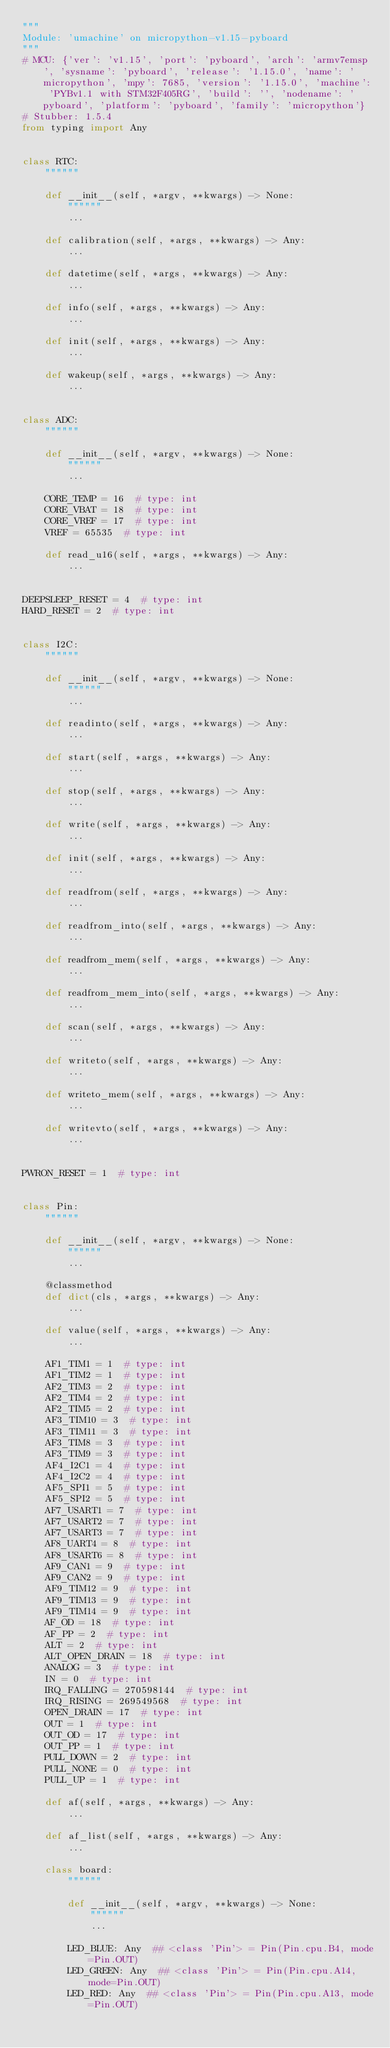<code> <loc_0><loc_0><loc_500><loc_500><_Python_>"""
Module: 'umachine' on micropython-v1.15-pyboard
"""
# MCU: {'ver': 'v1.15', 'port': 'pyboard', 'arch': 'armv7emsp', 'sysname': 'pyboard', 'release': '1.15.0', 'name': 'micropython', 'mpy': 7685, 'version': '1.15.0', 'machine': 'PYBv1.1 with STM32F405RG', 'build': '', 'nodename': 'pyboard', 'platform': 'pyboard', 'family': 'micropython'}
# Stubber: 1.5.4
from typing import Any


class RTC:
    """"""

    def __init__(self, *argv, **kwargs) -> None:
        """"""
        ...

    def calibration(self, *args, **kwargs) -> Any:
        ...

    def datetime(self, *args, **kwargs) -> Any:
        ...

    def info(self, *args, **kwargs) -> Any:
        ...

    def init(self, *args, **kwargs) -> Any:
        ...

    def wakeup(self, *args, **kwargs) -> Any:
        ...


class ADC:
    """"""

    def __init__(self, *argv, **kwargs) -> None:
        """"""
        ...

    CORE_TEMP = 16  # type: int
    CORE_VBAT = 18  # type: int
    CORE_VREF = 17  # type: int
    VREF = 65535  # type: int

    def read_u16(self, *args, **kwargs) -> Any:
        ...


DEEPSLEEP_RESET = 4  # type: int
HARD_RESET = 2  # type: int


class I2C:
    """"""

    def __init__(self, *argv, **kwargs) -> None:
        """"""
        ...

    def readinto(self, *args, **kwargs) -> Any:
        ...

    def start(self, *args, **kwargs) -> Any:
        ...

    def stop(self, *args, **kwargs) -> Any:
        ...

    def write(self, *args, **kwargs) -> Any:
        ...

    def init(self, *args, **kwargs) -> Any:
        ...

    def readfrom(self, *args, **kwargs) -> Any:
        ...

    def readfrom_into(self, *args, **kwargs) -> Any:
        ...

    def readfrom_mem(self, *args, **kwargs) -> Any:
        ...

    def readfrom_mem_into(self, *args, **kwargs) -> Any:
        ...

    def scan(self, *args, **kwargs) -> Any:
        ...

    def writeto(self, *args, **kwargs) -> Any:
        ...

    def writeto_mem(self, *args, **kwargs) -> Any:
        ...

    def writevto(self, *args, **kwargs) -> Any:
        ...


PWRON_RESET = 1  # type: int


class Pin:
    """"""

    def __init__(self, *argv, **kwargs) -> None:
        """"""
        ...

    @classmethod
    def dict(cls, *args, **kwargs) -> Any:
        ...

    def value(self, *args, **kwargs) -> Any:
        ...

    AF1_TIM1 = 1  # type: int
    AF1_TIM2 = 1  # type: int
    AF2_TIM3 = 2  # type: int
    AF2_TIM4 = 2  # type: int
    AF2_TIM5 = 2  # type: int
    AF3_TIM10 = 3  # type: int
    AF3_TIM11 = 3  # type: int
    AF3_TIM8 = 3  # type: int
    AF3_TIM9 = 3  # type: int
    AF4_I2C1 = 4  # type: int
    AF4_I2C2 = 4  # type: int
    AF5_SPI1 = 5  # type: int
    AF5_SPI2 = 5  # type: int
    AF7_USART1 = 7  # type: int
    AF7_USART2 = 7  # type: int
    AF7_USART3 = 7  # type: int
    AF8_UART4 = 8  # type: int
    AF8_USART6 = 8  # type: int
    AF9_CAN1 = 9  # type: int
    AF9_CAN2 = 9  # type: int
    AF9_TIM12 = 9  # type: int
    AF9_TIM13 = 9  # type: int
    AF9_TIM14 = 9  # type: int
    AF_OD = 18  # type: int
    AF_PP = 2  # type: int
    ALT = 2  # type: int
    ALT_OPEN_DRAIN = 18  # type: int
    ANALOG = 3  # type: int
    IN = 0  # type: int
    IRQ_FALLING = 270598144  # type: int
    IRQ_RISING = 269549568  # type: int
    OPEN_DRAIN = 17  # type: int
    OUT = 1  # type: int
    OUT_OD = 17  # type: int
    OUT_PP = 1  # type: int
    PULL_DOWN = 2  # type: int
    PULL_NONE = 0  # type: int
    PULL_UP = 1  # type: int

    def af(self, *args, **kwargs) -> Any:
        ...

    def af_list(self, *args, **kwargs) -> Any:
        ...

    class board:
        """"""

        def __init__(self, *argv, **kwargs) -> None:
            """"""
            ...

        LED_BLUE: Any  ## <class 'Pin'> = Pin(Pin.cpu.B4, mode=Pin.OUT)
        LED_GREEN: Any  ## <class 'Pin'> = Pin(Pin.cpu.A14, mode=Pin.OUT)
        LED_RED: Any  ## <class 'Pin'> = Pin(Pin.cpu.A13, mode=Pin.OUT)</code> 